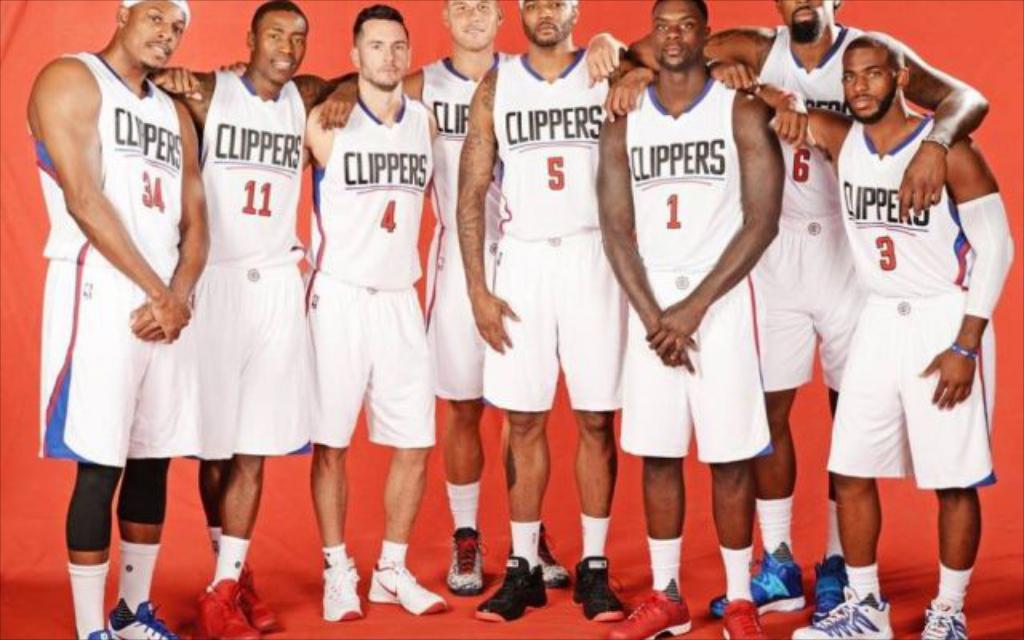<image>
Describe the image concisely. The LA Clippers stand together as a team. 